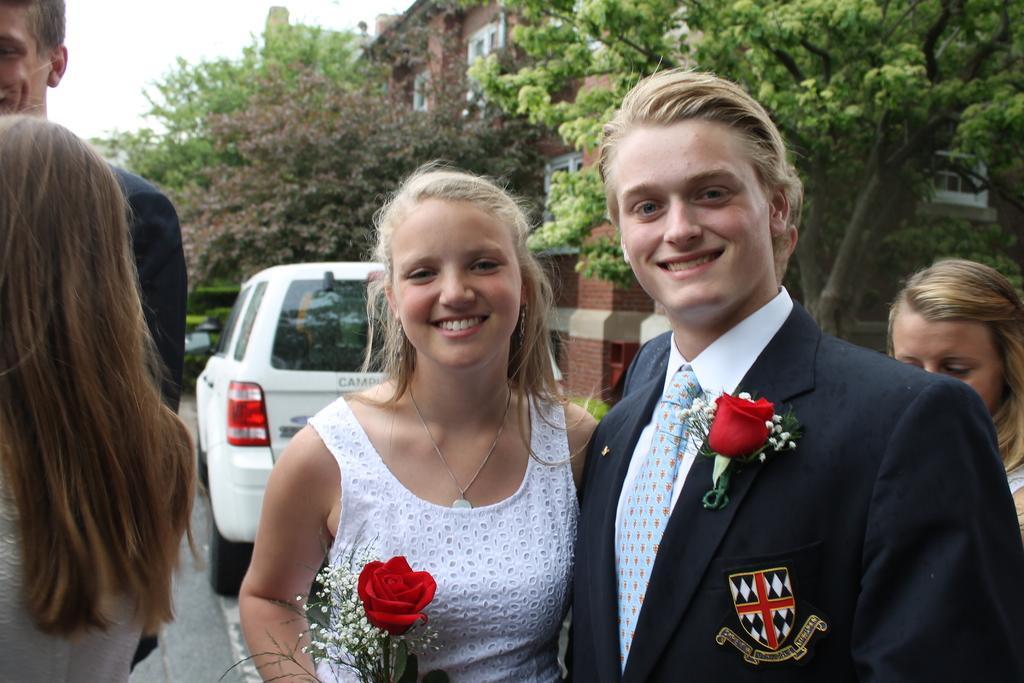In one or two sentences, can you explain what this image depicts? In the image we can see there are people standing and the woman is holding rose in her hand. Behind there are trees and building. There is a clear sky. 